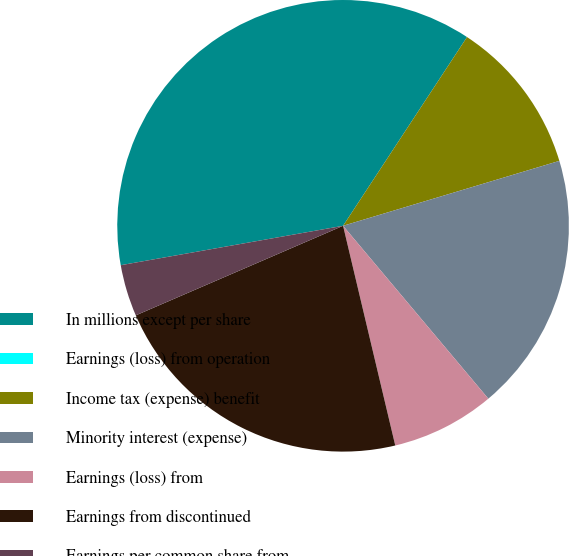Convert chart. <chart><loc_0><loc_0><loc_500><loc_500><pie_chart><fcel>In millions except per share<fcel>Earnings (loss) from operation<fcel>Income tax (expense) benefit<fcel>Minority interest (expense)<fcel>Earnings (loss) from<fcel>Earnings from discontinued<fcel>Earnings per common share from<nl><fcel>37.04%<fcel>0.0%<fcel>11.11%<fcel>18.52%<fcel>7.41%<fcel>22.22%<fcel>3.7%<nl></chart> 